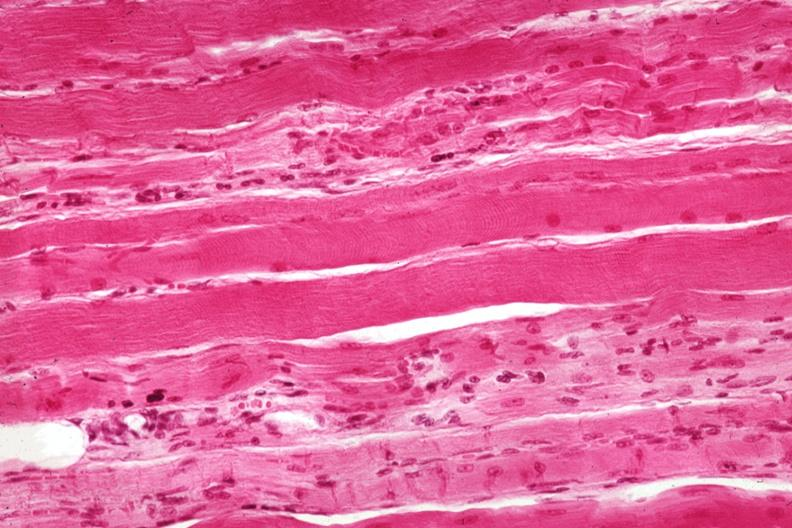what is present?
Answer the question using a single word or phrase. Soft tissue 